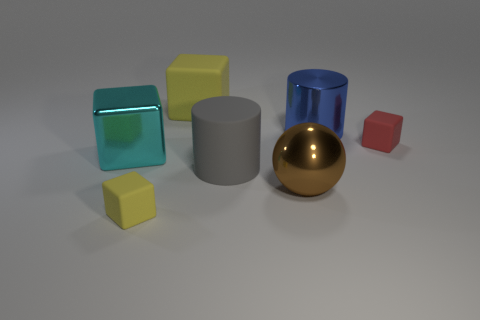Subtract all metal cubes. How many cubes are left? 3 Subtract all gray cylinders. How many cylinders are left? 1 Subtract all cubes. How many objects are left? 3 Subtract all gray cubes. Subtract all red cylinders. How many cubes are left? 4 Subtract all brown balls. How many red blocks are left? 1 Subtract all gray rubber things. Subtract all big gray objects. How many objects are left? 5 Add 2 gray rubber cylinders. How many gray rubber cylinders are left? 3 Add 1 big shiny balls. How many big shiny balls exist? 2 Add 3 red rubber objects. How many objects exist? 10 Subtract 0 brown blocks. How many objects are left? 7 